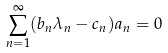<formula> <loc_0><loc_0><loc_500><loc_500>\sum _ { n = 1 } ^ { \infty } ( b _ { n } \lambda _ { n } - c _ { n } ) a _ { n } = 0</formula> 